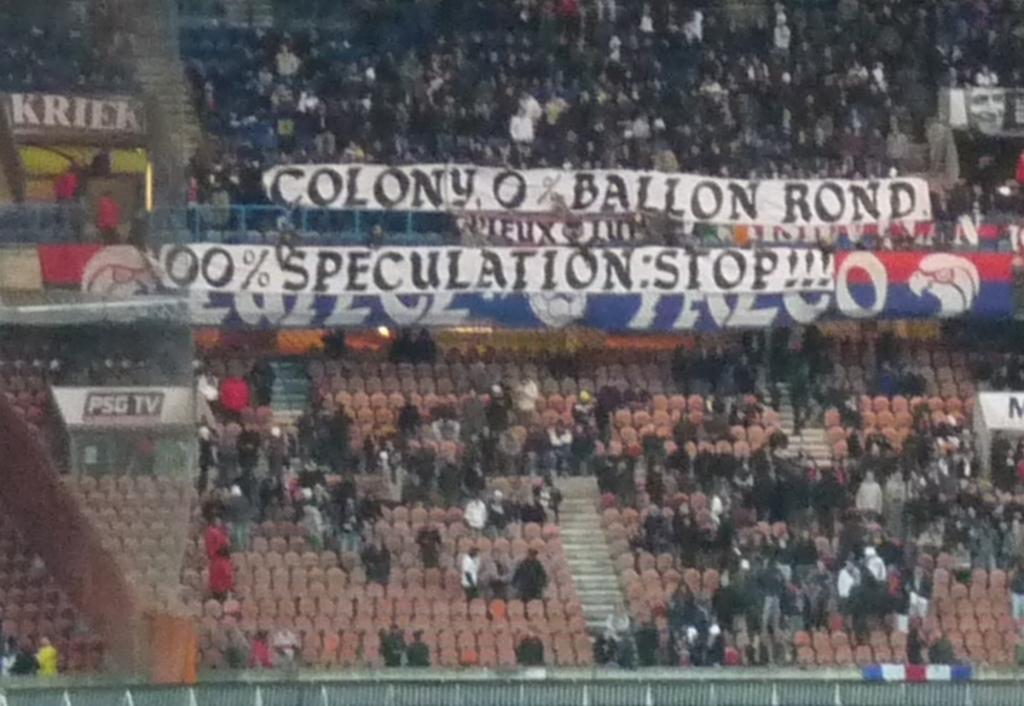<image>
Relay a brief, clear account of the picture shown. A set of bleachers about half full with a large banner reading speculation stop. 